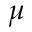Convert formula to latex. <formula><loc_0><loc_0><loc_500><loc_500>\mu</formula> 